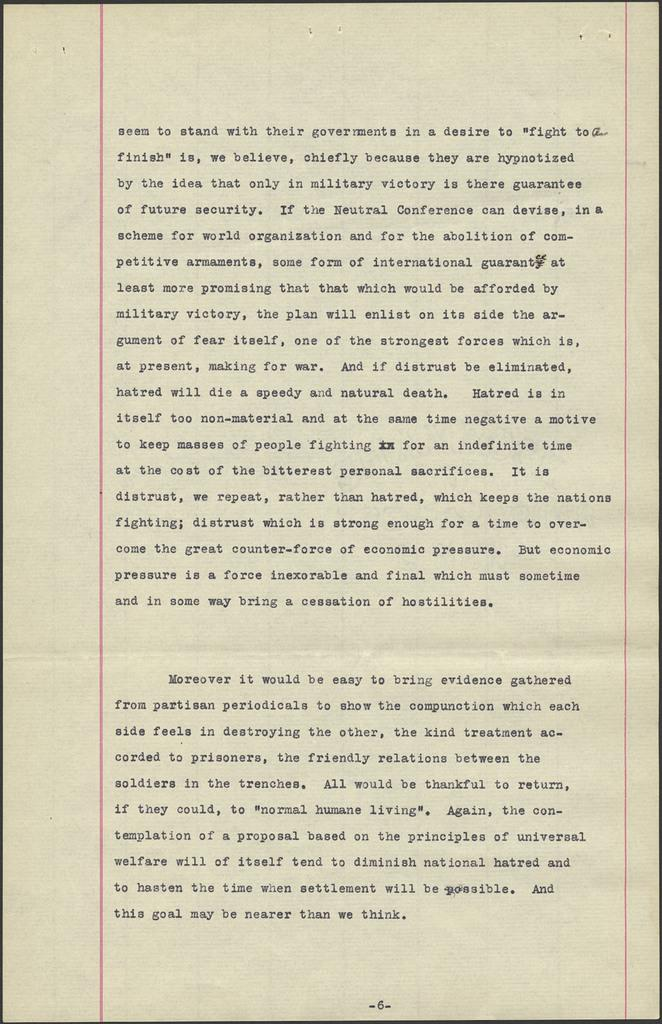What is present in the image? There is a paper in the image. What can be seen on the paper? There is writing in the center of the paper, and there is a page number at the bottom of the paper. What thrilling activity is happening at the cemetery in the image? There is no cemetery or thrilling activity present in the image; it only features a paper with writing and a page number. 